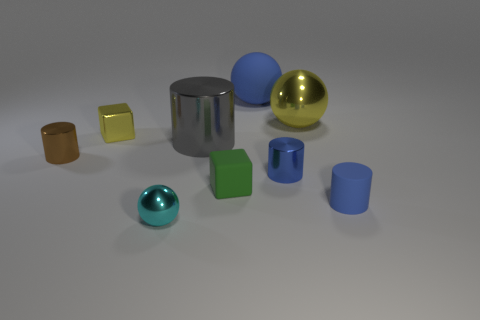What number of things are tiny blue things behind the tiny rubber cylinder or blue rubber objects in front of the tiny brown object?
Offer a very short reply. 2. What shape is the object that is both on the left side of the tiny green rubber cube and behind the big gray object?
Your response must be concise. Cube. How many big yellow shiny balls are left of the yellow metallic thing that is to the left of the large cylinder?
Give a very brief answer. 0. How many things are either large shiny cylinders that are behind the small blue matte object or big blue things?
Provide a succinct answer. 2. There is a blue matte object behind the green cube; how big is it?
Provide a succinct answer. Large. What material is the tiny green block?
Give a very brief answer. Rubber. There is a tiny matte object behind the small cylinder to the right of the small blue metal thing; what is its shape?
Your response must be concise. Cube. What number of other objects are there of the same shape as the blue metal object?
Your response must be concise. 3. Are there any big objects behind the tiny yellow metal object?
Keep it short and to the point. Yes. The big shiny sphere is what color?
Provide a succinct answer. Yellow. 